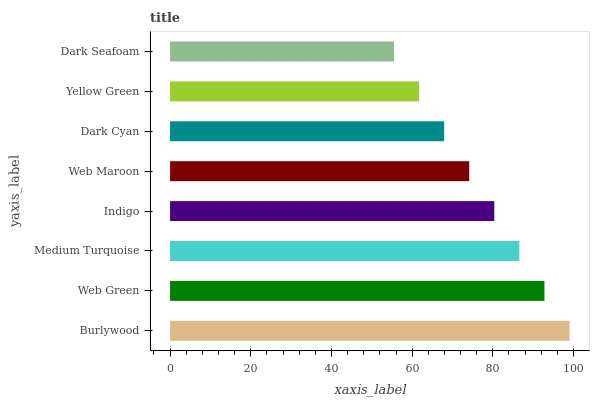Is Dark Seafoam the minimum?
Answer yes or no. Yes. Is Burlywood the maximum?
Answer yes or no. Yes. Is Web Green the minimum?
Answer yes or no. No. Is Web Green the maximum?
Answer yes or no. No. Is Burlywood greater than Web Green?
Answer yes or no. Yes. Is Web Green less than Burlywood?
Answer yes or no. Yes. Is Web Green greater than Burlywood?
Answer yes or no. No. Is Burlywood less than Web Green?
Answer yes or no. No. Is Indigo the high median?
Answer yes or no. Yes. Is Web Maroon the low median?
Answer yes or no. Yes. Is Web Maroon the high median?
Answer yes or no. No. Is Indigo the low median?
Answer yes or no. No. 